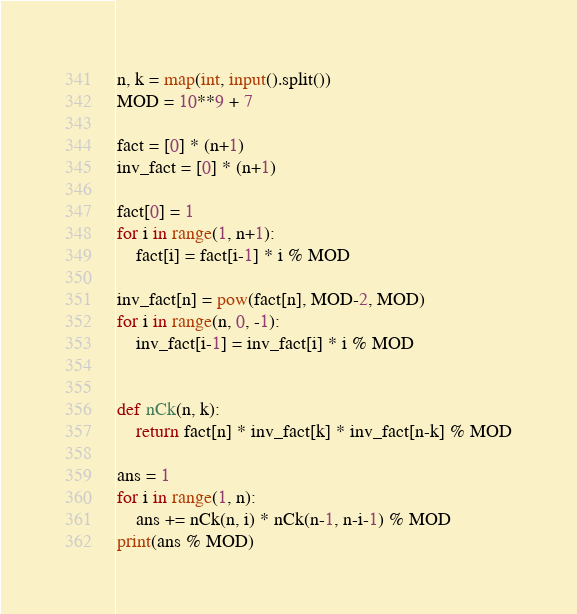Convert code to text. <code><loc_0><loc_0><loc_500><loc_500><_Python_>n, k = map(int, input().split())
MOD = 10**9 + 7

fact = [0] * (n+1)
inv_fact = [0] * (n+1)

fact[0] = 1
for i in range(1, n+1):
    fact[i] = fact[i-1] * i % MOD

inv_fact[n] = pow(fact[n], MOD-2, MOD)
for i in range(n, 0, -1):
    inv_fact[i-1] = inv_fact[i] * i % MOD


def nCk(n, k):
    return fact[n] * inv_fact[k] * inv_fact[n-k] % MOD
  
ans = 1
for i in range(1, n):
    ans += nCk(n, i) * nCk(n-1, n-i-1) % MOD
print(ans % MOD)</code> 